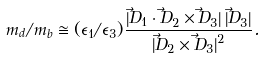<formula> <loc_0><loc_0><loc_500><loc_500>m _ { d } / m _ { b } \cong ( \epsilon _ { 1 } / \epsilon _ { 3 } ) \frac { \left | \vec { D } _ { 1 } \cdot \vec { D } _ { 2 } \times \vec { D } _ { 3 } \right | \left | \vec { D } _ { 3 } \right | } { \left | \vec { D } _ { 2 } \times \vec { D } _ { 3 } \right | ^ { 2 } } .</formula> 